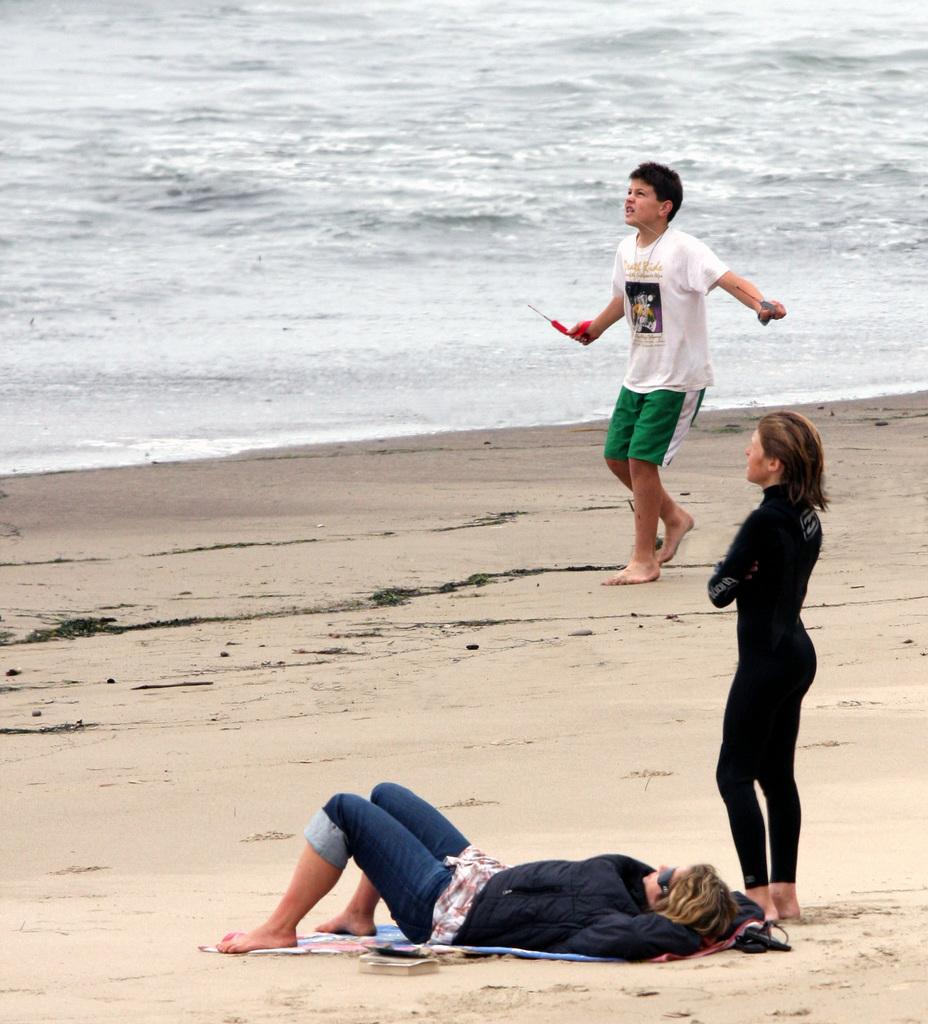Where was the image taken? The image was taken at the beach. Can you describe the people in the image? There are people in the image, but their specific actions or appearances are not mentioned in the provided facts. What type of terrain is visible in the image? There is sand visible in the image. What natural element is also present in the image? There is water visible in the image. What type of pear is being sold at the downtown market in the image? There is no downtown market or pear present in the image; it was taken at the beach. Can you see a badge on any of the people in the image? There is no mention of a badge or any specific clothing or accessories in the image, so it cannot be determined if one is present. 